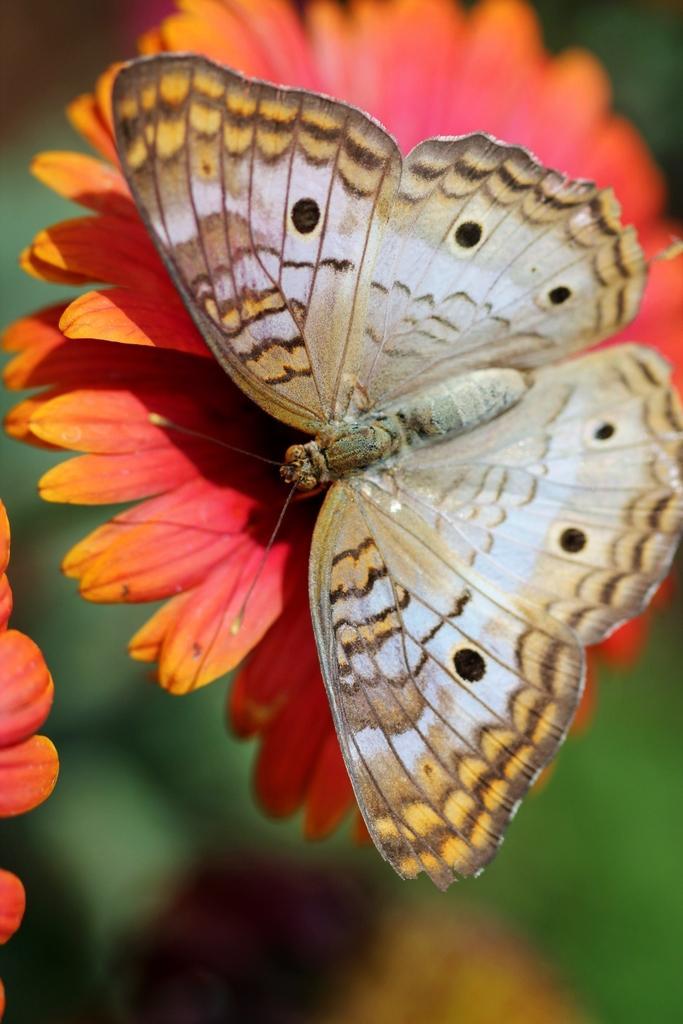Describe this image in one or two sentences. In this image we can see a butterfly on a flower with blurry background. 